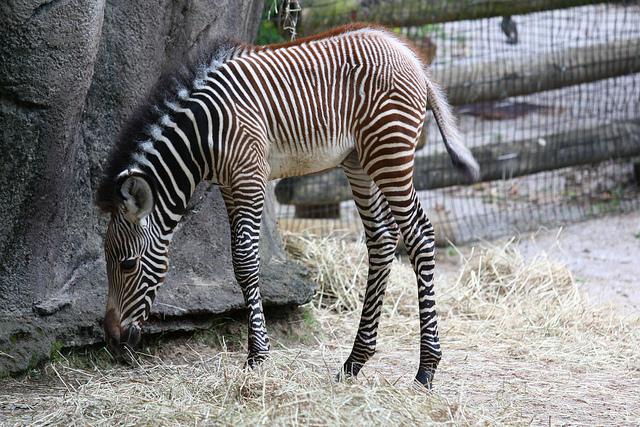Is the zebra grazing?
Quick response, please. Yes. Is the zebra in a confined area?
Keep it brief. Yes. Is the zebra full grown?
Give a very brief answer. No. Is the zebra in captivity or its natural habitat?
Answer briefly. Captivity. 